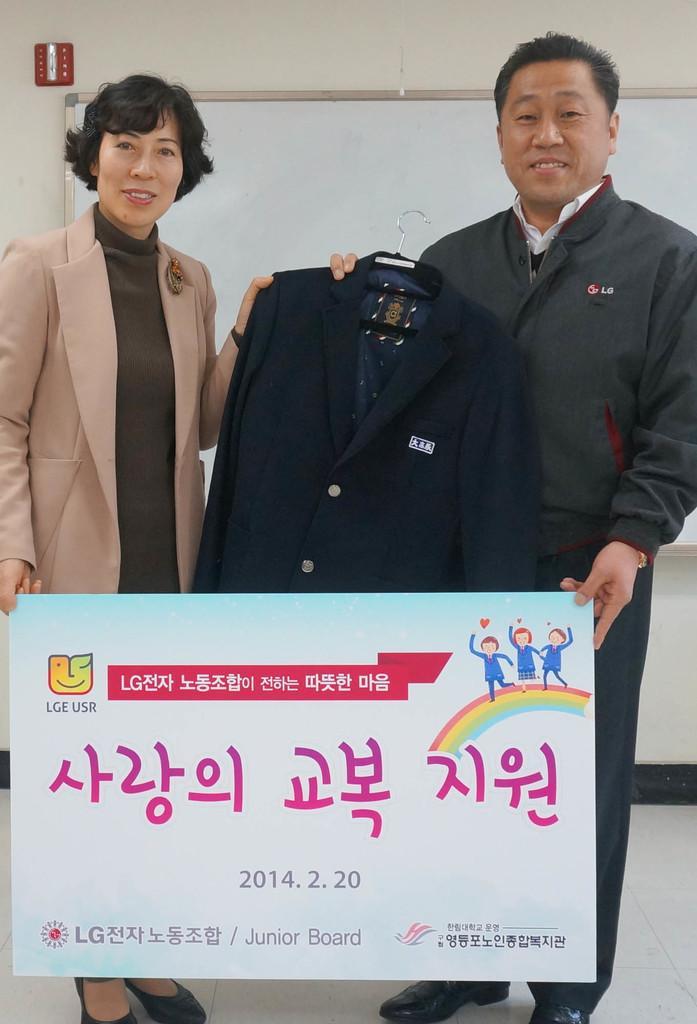Please provide a concise description of this image. In this image we can see a man and a woman holding a board and a coat with a hanger. On the backside we can see a board and a wall. 